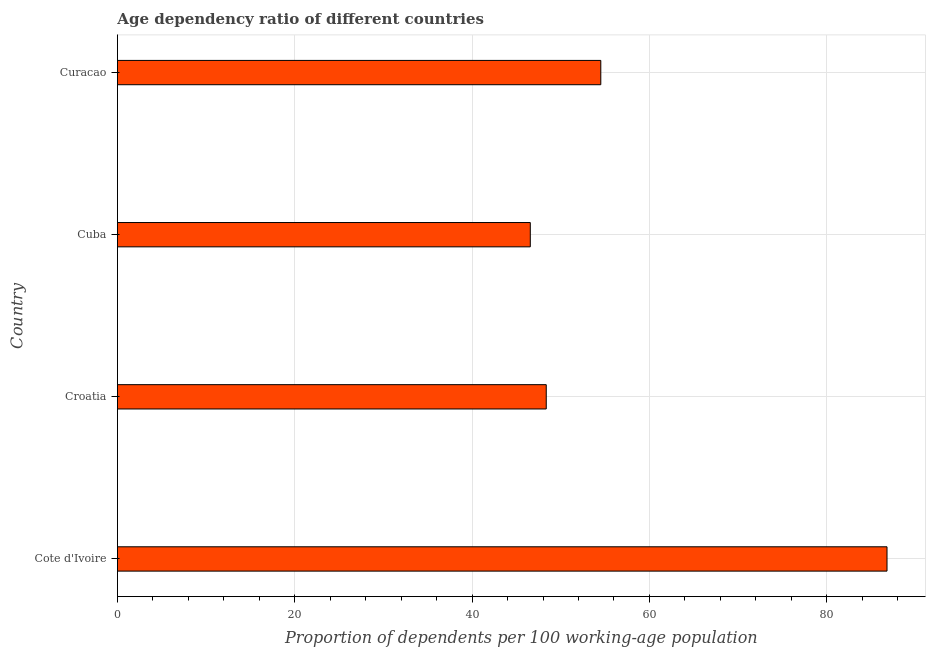Does the graph contain any zero values?
Your answer should be compact. No. Does the graph contain grids?
Offer a terse response. Yes. What is the title of the graph?
Give a very brief answer. Age dependency ratio of different countries. What is the label or title of the X-axis?
Make the answer very short. Proportion of dependents per 100 working-age population. What is the age dependency ratio in Croatia?
Give a very brief answer. 48.37. Across all countries, what is the maximum age dependency ratio?
Offer a very short reply. 86.8. Across all countries, what is the minimum age dependency ratio?
Your response must be concise. 46.57. In which country was the age dependency ratio maximum?
Keep it short and to the point. Cote d'Ivoire. In which country was the age dependency ratio minimum?
Make the answer very short. Cuba. What is the sum of the age dependency ratio?
Your answer should be very brief. 236.25. What is the difference between the age dependency ratio in Cuba and Curacao?
Provide a succinct answer. -7.95. What is the average age dependency ratio per country?
Ensure brevity in your answer.  59.06. What is the median age dependency ratio?
Provide a short and direct response. 51.44. What is the ratio of the age dependency ratio in Croatia to that in Curacao?
Keep it short and to the point. 0.89. Is the age dependency ratio in Croatia less than that in Curacao?
Provide a succinct answer. Yes. What is the difference between the highest and the second highest age dependency ratio?
Your answer should be compact. 32.28. What is the difference between the highest and the lowest age dependency ratio?
Your answer should be compact. 40.23. How many bars are there?
Offer a very short reply. 4. Are all the bars in the graph horizontal?
Ensure brevity in your answer.  Yes. How many countries are there in the graph?
Keep it short and to the point. 4. Are the values on the major ticks of X-axis written in scientific E-notation?
Make the answer very short. No. What is the Proportion of dependents per 100 working-age population in Cote d'Ivoire?
Your response must be concise. 86.8. What is the Proportion of dependents per 100 working-age population in Croatia?
Give a very brief answer. 48.37. What is the Proportion of dependents per 100 working-age population in Cuba?
Make the answer very short. 46.57. What is the Proportion of dependents per 100 working-age population of Curacao?
Give a very brief answer. 54.52. What is the difference between the Proportion of dependents per 100 working-age population in Cote d'Ivoire and Croatia?
Your answer should be very brief. 38.43. What is the difference between the Proportion of dependents per 100 working-age population in Cote d'Ivoire and Cuba?
Make the answer very short. 40.23. What is the difference between the Proportion of dependents per 100 working-age population in Cote d'Ivoire and Curacao?
Offer a very short reply. 32.28. What is the difference between the Proportion of dependents per 100 working-age population in Croatia and Cuba?
Your answer should be very brief. 1.8. What is the difference between the Proportion of dependents per 100 working-age population in Croatia and Curacao?
Provide a short and direct response. -6.15. What is the difference between the Proportion of dependents per 100 working-age population in Cuba and Curacao?
Give a very brief answer. -7.95. What is the ratio of the Proportion of dependents per 100 working-age population in Cote d'Ivoire to that in Croatia?
Your answer should be very brief. 1.79. What is the ratio of the Proportion of dependents per 100 working-age population in Cote d'Ivoire to that in Cuba?
Offer a terse response. 1.86. What is the ratio of the Proportion of dependents per 100 working-age population in Cote d'Ivoire to that in Curacao?
Make the answer very short. 1.59. What is the ratio of the Proportion of dependents per 100 working-age population in Croatia to that in Cuba?
Offer a terse response. 1.04. What is the ratio of the Proportion of dependents per 100 working-age population in Croatia to that in Curacao?
Your answer should be compact. 0.89. What is the ratio of the Proportion of dependents per 100 working-age population in Cuba to that in Curacao?
Make the answer very short. 0.85. 